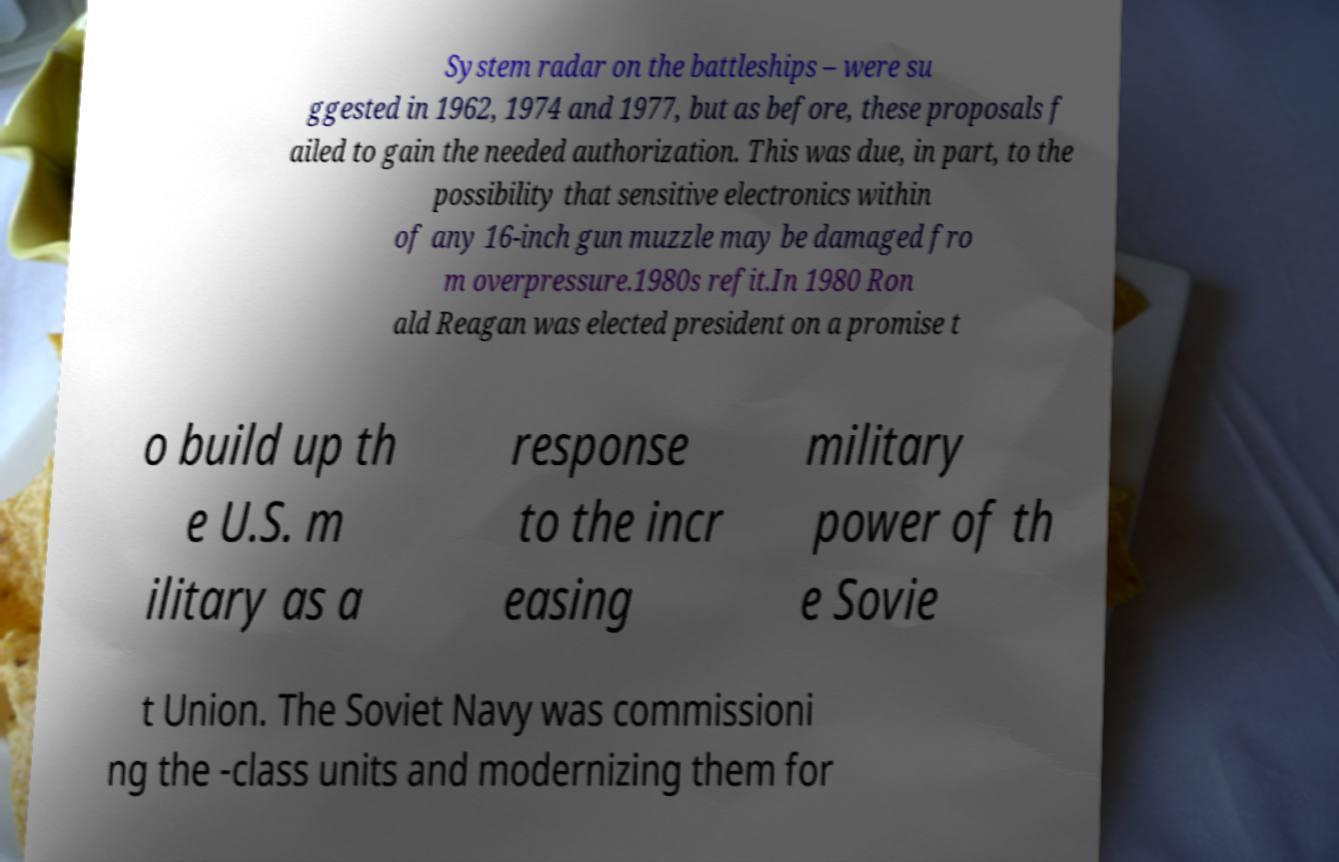For documentation purposes, I need the text within this image transcribed. Could you provide that? System radar on the battleships – were su ggested in 1962, 1974 and 1977, but as before, these proposals f ailed to gain the needed authorization. This was due, in part, to the possibility that sensitive electronics within of any 16-inch gun muzzle may be damaged fro m overpressure.1980s refit.In 1980 Ron ald Reagan was elected president on a promise t o build up th e U.S. m ilitary as a response to the incr easing military power of th e Sovie t Union. The Soviet Navy was commissioni ng the -class units and modernizing them for 